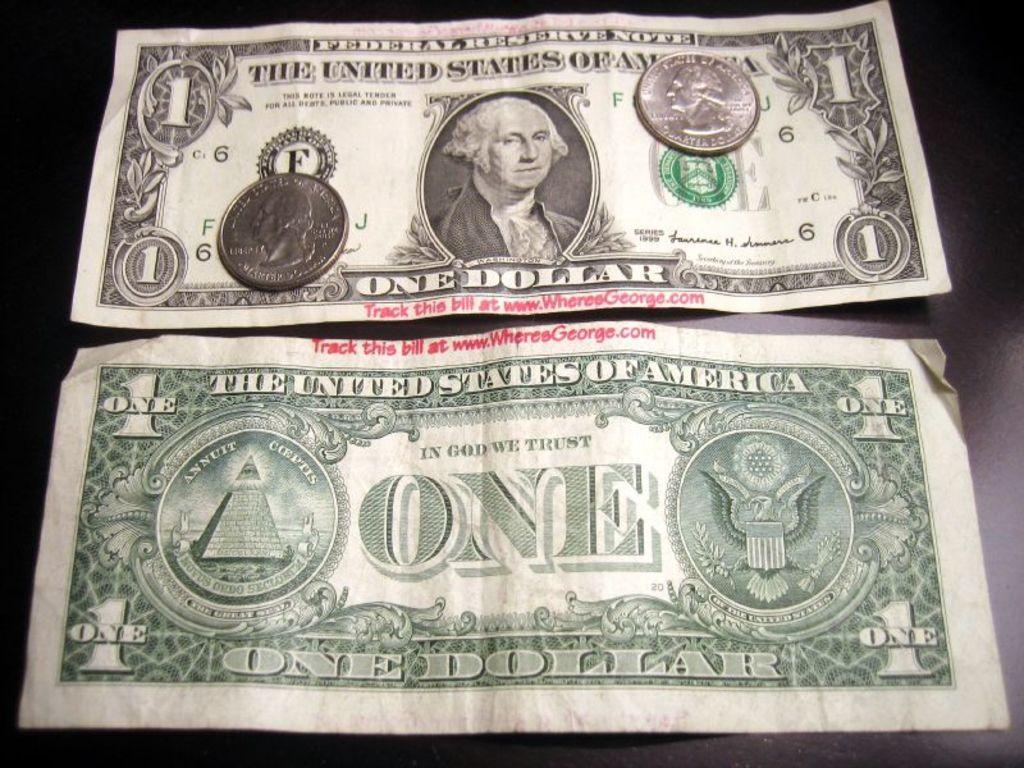In one or two sentences, can you explain what this image depicts? In this image we can see there are currency notes and coins on the surface. 